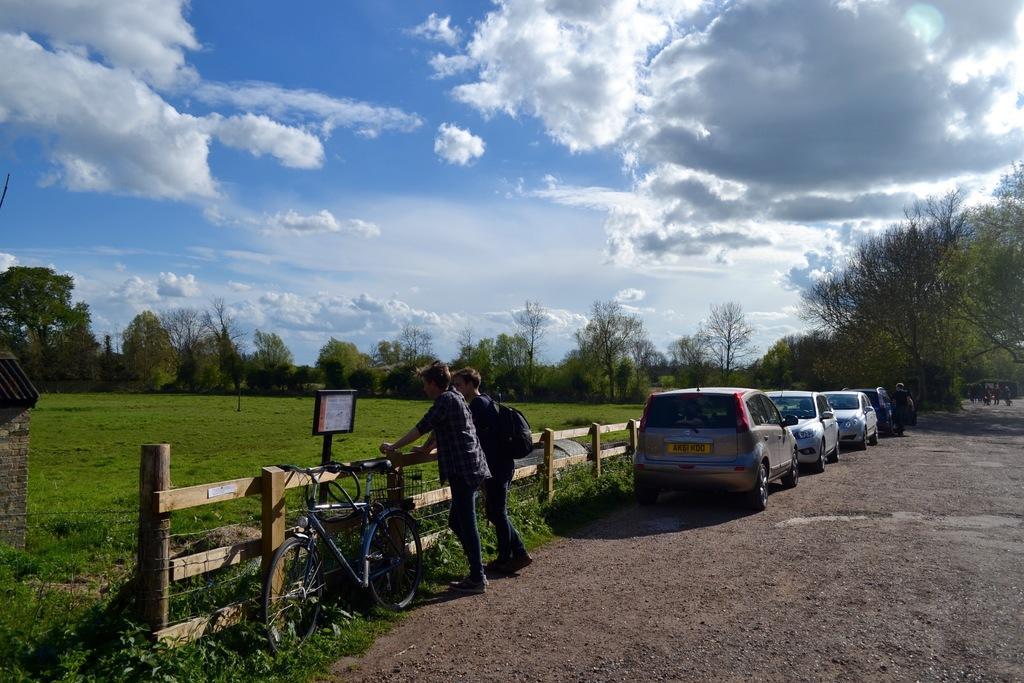In one or two sentences, can you explain what this image depicts? In this image there are cars on a road and two people are standing near a wooden railing and there is a cycle, in the background there is a grassland, trees and the sky. 